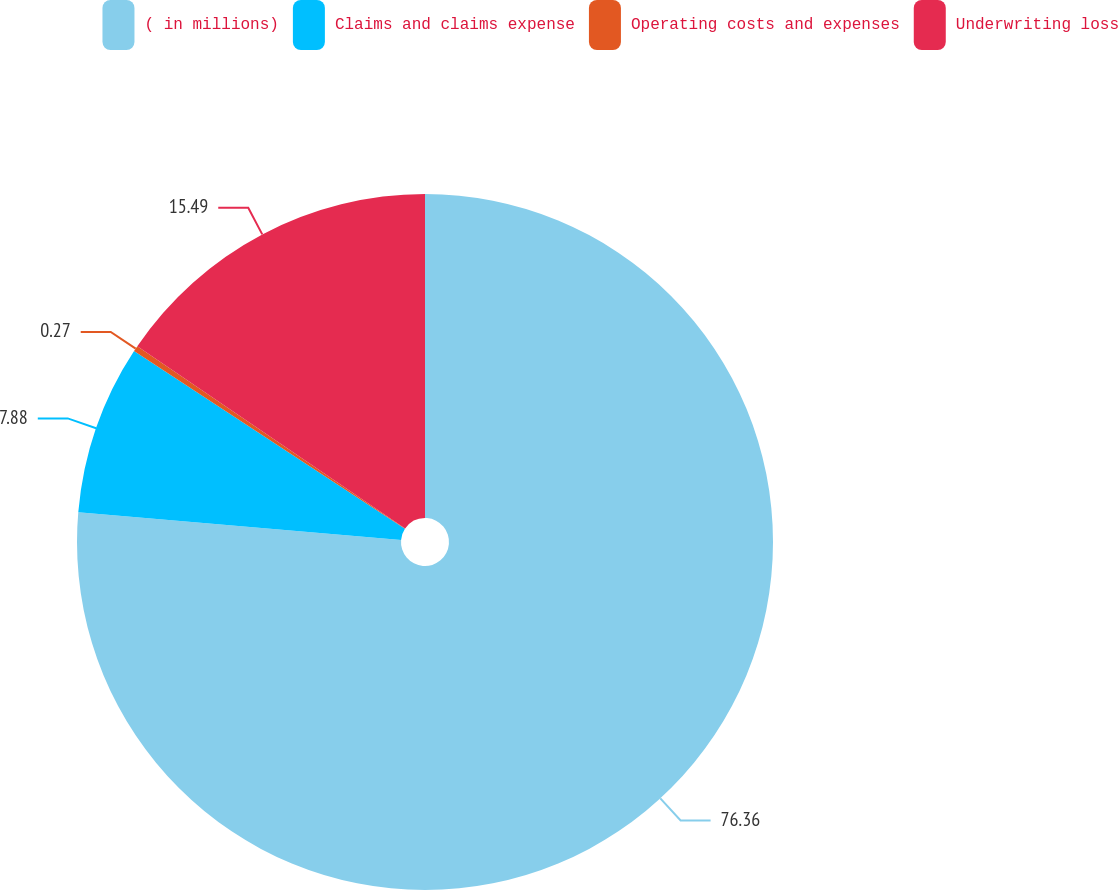Convert chart. <chart><loc_0><loc_0><loc_500><loc_500><pie_chart><fcel>( in millions)<fcel>Claims and claims expense<fcel>Operating costs and expenses<fcel>Underwriting loss<nl><fcel>76.37%<fcel>7.88%<fcel>0.27%<fcel>15.49%<nl></chart> 